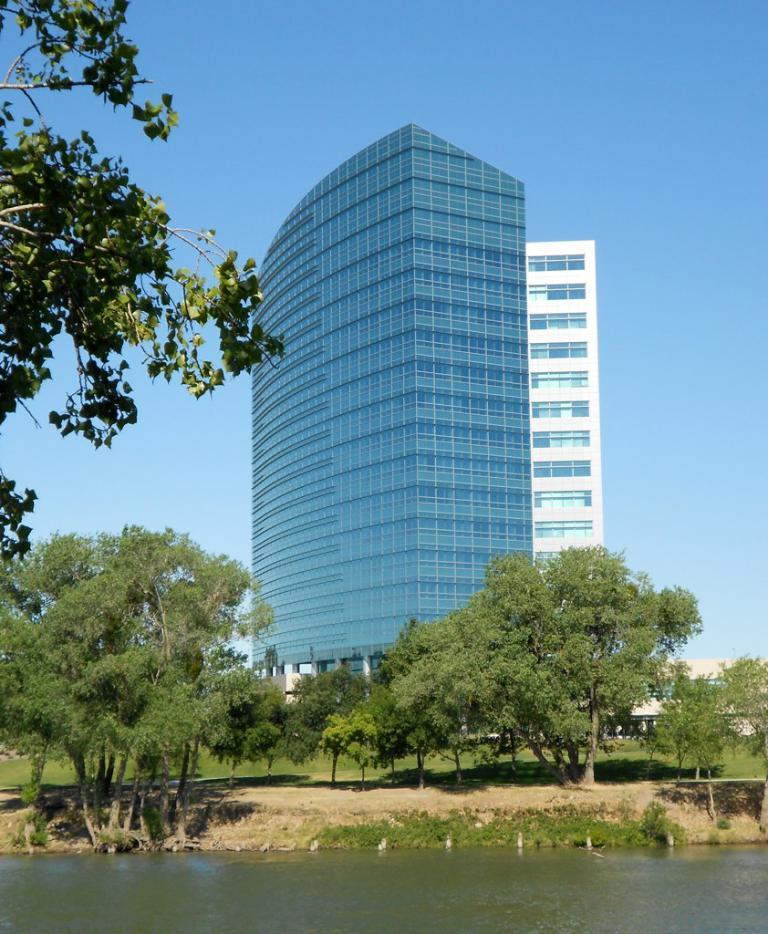What type of structures can be seen in the image? There are buildings in the image. What type of vegetation is present in the image? There are trees and plants in the image. What is visible on the ground in the image? The ground is visible in the image, and there is grass present. What natural element can be seen in the image? Water is visible in the image. What part of the natural environment is visible in the image? The sky is visible in the image. What degree of heat is the pickle experiencing in the image? There is no pickle present in the image, so it is not possible to determine the degree of heat it might be experiencing. 